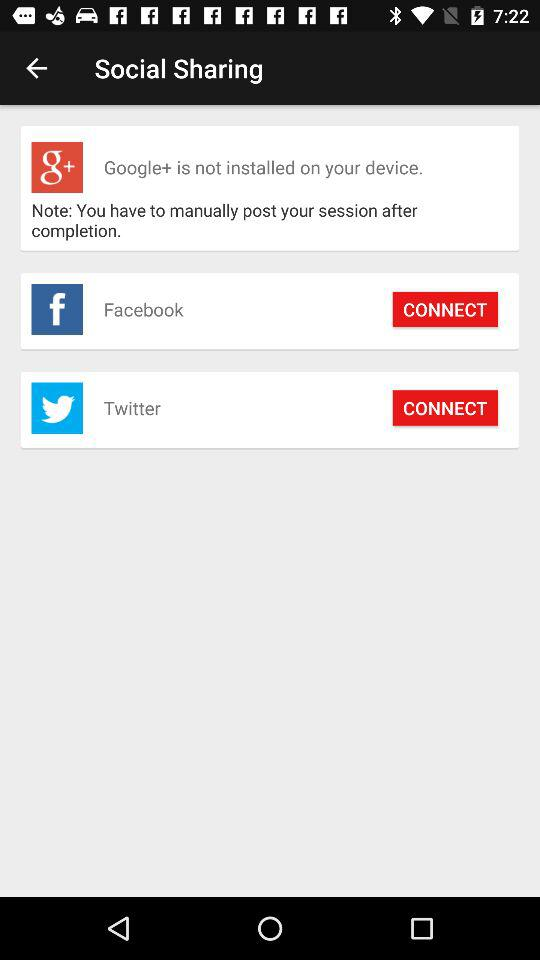How many social sharing options are available that are not Twitter?
Answer the question using a single word or phrase. 1 